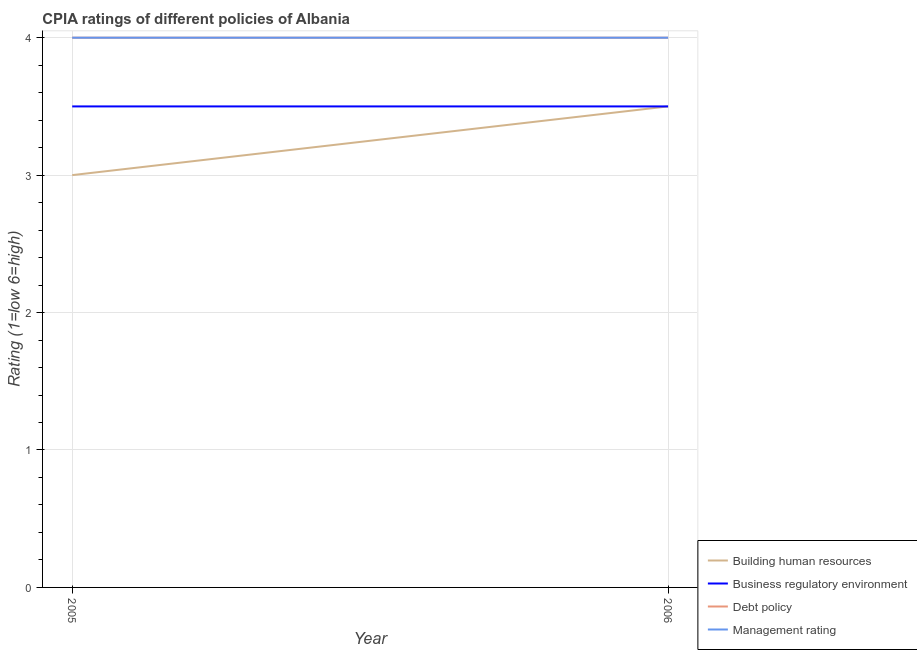Across all years, what is the maximum cpia rating of business regulatory environment?
Ensure brevity in your answer.  3.5. Across all years, what is the minimum cpia rating of management?
Your response must be concise. 4. In which year was the cpia rating of building human resources maximum?
Give a very brief answer. 2006. What is the total cpia rating of debt policy in the graph?
Offer a terse response. 8. What is the difference between the cpia rating of business regulatory environment in 2006 and the cpia rating of debt policy in 2005?
Your answer should be compact. -0.5. What is the ratio of the cpia rating of building human resources in 2005 to that in 2006?
Offer a terse response. 0.86. Is the cpia rating of business regulatory environment in 2005 less than that in 2006?
Your answer should be compact. No. In how many years, is the cpia rating of building human resources greater than the average cpia rating of building human resources taken over all years?
Give a very brief answer. 1. Is it the case that in every year, the sum of the cpia rating of building human resources and cpia rating of business regulatory environment is greater than the cpia rating of debt policy?
Ensure brevity in your answer.  Yes. Is the cpia rating of business regulatory environment strictly greater than the cpia rating of building human resources over the years?
Make the answer very short. No. Is the cpia rating of building human resources strictly less than the cpia rating of business regulatory environment over the years?
Ensure brevity in your answer.  No. How many lines are there?
Provide a short and direct response. 4. Does the graph contain any zero values?
Your answer should be compact. No. Does the graph contain grids?
Give a very brief answer. Yes. How many legend labels are there?
Offer a very short reply. 4. How are the legend labels stacked?
Provide a short and direct response. Vertical. What is the title of the graph?
Make the answer very short. CPIA ratings of different policies of Albania. What is the label or title of the X-axis?
Provide a succinct answer. Year. What is the Rating (1=low 6=high) in Building human resources in 2005?
Make the answer very short. 3. What is the Rating (1=low 6=high) in Business regulatory environment in 2005?
Your response must be concise. 3.5. What is the Rating (1=low 6=high) of Management rating in 2005?
Offer a very short reply. 4. What is the Rating (1=low 6=high) in Business regulatory environment in 2006?
Provide a short and direct response. 3.5. What is the Rating (1=low 6=high) in Management rating in 2006?
Keep it short and to the point. 4. Across all years, what is the maximum Rating (1=low 6=high) of Building human resources?
Your answer should be very brief. 3.5. Across all years, what is the maximum Rating (1=low 6=high) of Business regulatory environment?
Your response must be concise. 3.5. Across all years, what is the maximum Rating (1=low 6=high) of Debt policy?
Provide a succinct answer. 4. Across all years, what is the maximum Rating (1=low 6=high) of Management rating?
Keep it short and to the point. 4. Across all years, what is the minimum Rating (1=low 6=high) in Business regulatory environment?
Keep it short and to the point. 3.5. Across all years, what is the minimum Rating (1=low 6=high) of Debt policy?
Offer a very short reply. 4. What is the total Rating (1=low 6=high) of Building human resources in the graph?
Your answer should be very brief. 6.5. What is the total Rating (1=low 6=high) of Debt policy in the graph?
Provide a short and direct response. 8. What is the total Rating (1=low 6=high) of Management rating in the graph?
Ensure brevity in your answer.  8. What is the difference between the Rating (1=low 6=high) of Building human resources in 2005 and that in 2006?
Your response must be concise. -0.5. What is the difference between the Rating (1=low 6=high) of Building human resources in 2005 and the Rating (1=low 6=high) of Debt policy in 2006?
Provide a succinct answer. -1. What is the difference between the Rating (1=low 6=high) in Debt policy in 2005 and the Rating (1=low 6=high) in Management rating in 2006?
Your answer should be compact. 0. What is the average Rating (1=low 6=high) in Building human resources per year?
Make the answer very short. 3.25. What is the average Rating (1=low 6=high) of Business regulatory environment per year?
Ensure brevity in your answer.  3.5. What is the average Rating (1=low 6=high) of Debt policy per year?
Provide a succinct answer. 4. In the year 2005, what is the difference between the Rating (1=low 6=high) of Building human resources and Rating (1=low 6=high) of Management rating?
Provide a short and direct response. -1. In the year 2005, what is the difference between the Rating (1=low 6=high) of Business regulatory environment and Rating (1=low 6=high) of Debt policy?
Provide a short and direct response. -0.5. In the year 2005, what is the difference between the Rating (1=low 6=high) in Business regulatory environment and Rating (1=low 6=high) in Management rating?
Make the answer very short. -0.5. In the year 2006, what is the difference between the Rating (1=low 6=high) of Building human resources and Rating (1=low 6=high) of Business regulatory environment?
Give a very brief answer. 0. In the year 2006, what is the difference between the Rating (1=low 6=high) of Building human resources and Rating (1=low 6=high) of Debt policy?
Offer a very short reply. -0.5. In the year 2006, what is the difference between the Rating (1=low 6=high) of Building human resources and Rating (1=low 6=high) of Management rating?
Provide a short and direct response. -0.5. In the year 2006, what is the difference between the Rating (1=low 6=high) in Business regulatory environment and Rating (1=low 6=high) in Management rating?
Your response must be concise. -0.5. In the year 2006, what is the difference between the Rating (1=low 6=high) in Debt policy and Rating (1=low 6=high) in Management rating?
Your answer should be compact. 0. What is the ratio of the Rating (1=low 6=high) in Business regulatory environment in 2005 to that in 2006?
Provide a short and direct response. 1. What is the ratio of the Rating (1=low 6=high) in Management rating in 2005 to that in 2006?
Provide a succinct answer. 1. What is the difference between the highest and the second highest Rating (1=low 6=high) in Building human resources?
Provide a succinct answer. 0.5. What is the difference between the highest and the second highest Rating (1=low 6=high) of Business regulatory environment?
Provide a short and direct response. 0. What is the difference between the highest and the second highest Rating (1=low 6=high) of Debt policy?
Provide a succinct answer. 0. What is the difference between the highest and the lowest Rating (1=low 6=high) of Debt policy?
Make the answer very short. 0. What is the difference between the highest and the lowest Rating (1=low 6=high) in Management rating?
Keep it short and to the point. 0. 